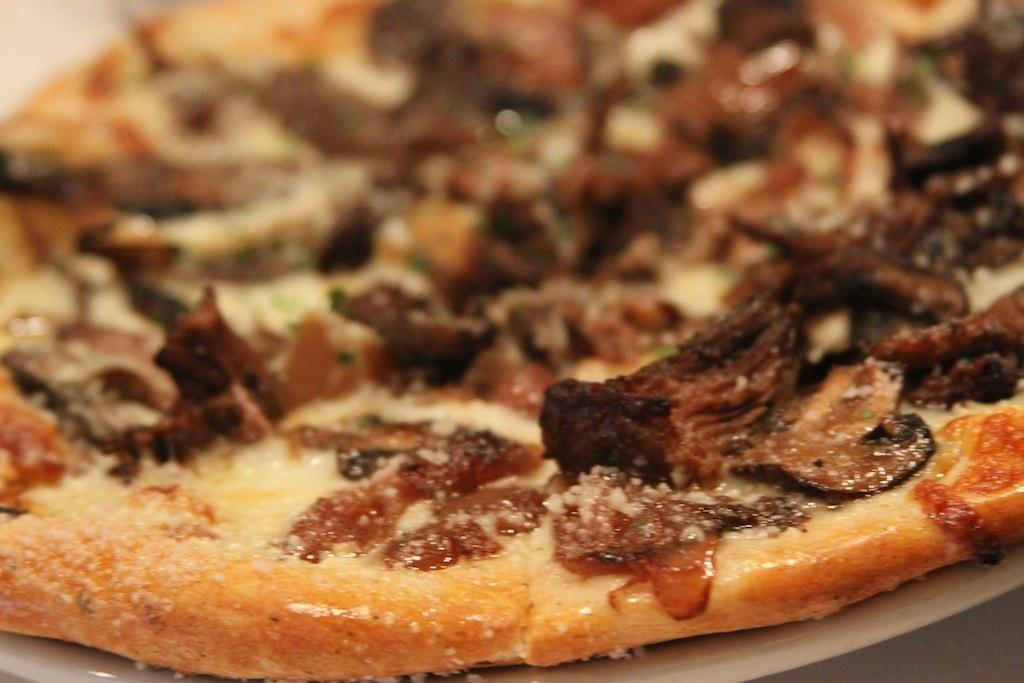What type of food can be seen in the image? The food in the image has brown and cream colors. How is the food arranged in the image? The food is in a plate. What color is the plate? The plate is white. Is there a fan visible in the image? No, there is no fan present in the image. Can you tell me how many drawers are in the image? There are no drawers visible in the image. 